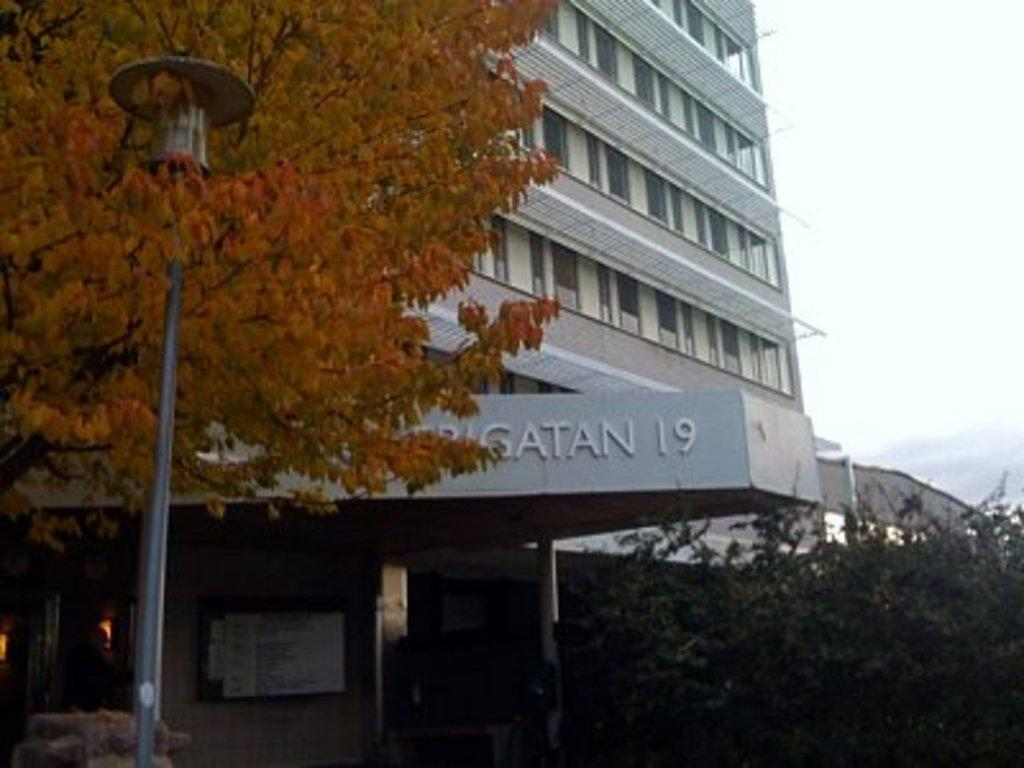What type of structures can be seen in the image? There are buildings in the image. What is the purpose of the object with a light on top? There is a street light in the image, which provides illumination for the area. What type of vegetation is present in the image? There are trees in the image. What can be seen in the distance in the image? The sky is visible in the background of the image. How many children are playing on the wing of the airplane in the image? There are no children or airplanes present in the image. What type of error can be seen in the image? There is no error visible in the image; it appears to be a clear and accurate representation of the scene. 